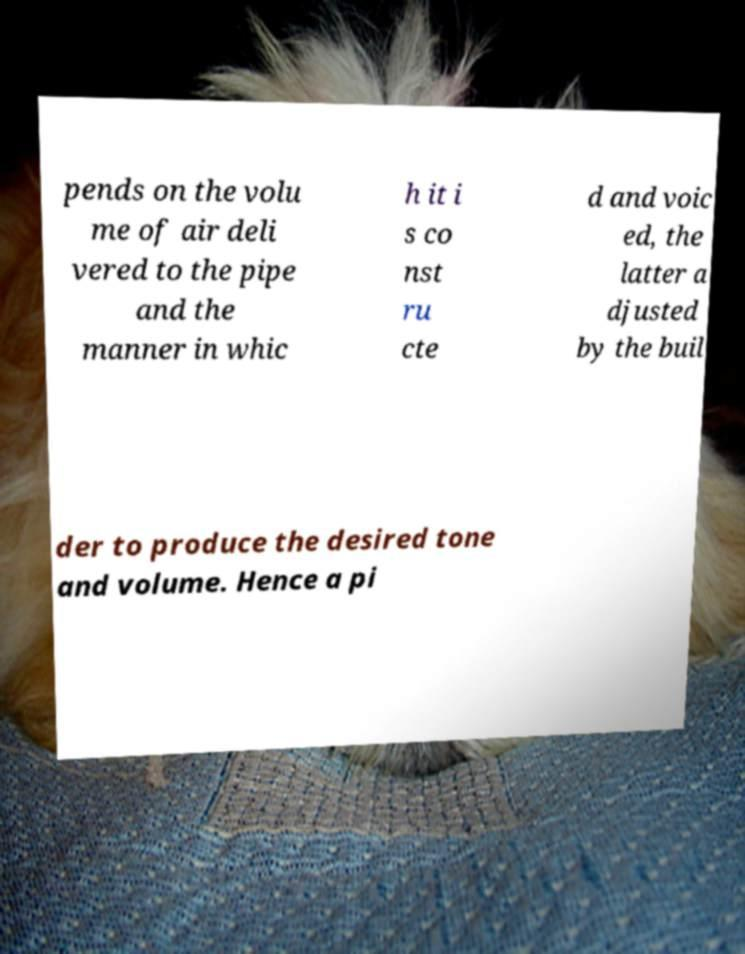Can you read and provide the text displayed in the image?This photo seems to have some interesting text. Can you extract and type it out for me? pends on the volu me of air deli vered to the pipe and the manner in whic h it i s co nst ru cte d and voic ed, the latter a djusted by the buil der to produce the desired tone and volume. Hence a pi 